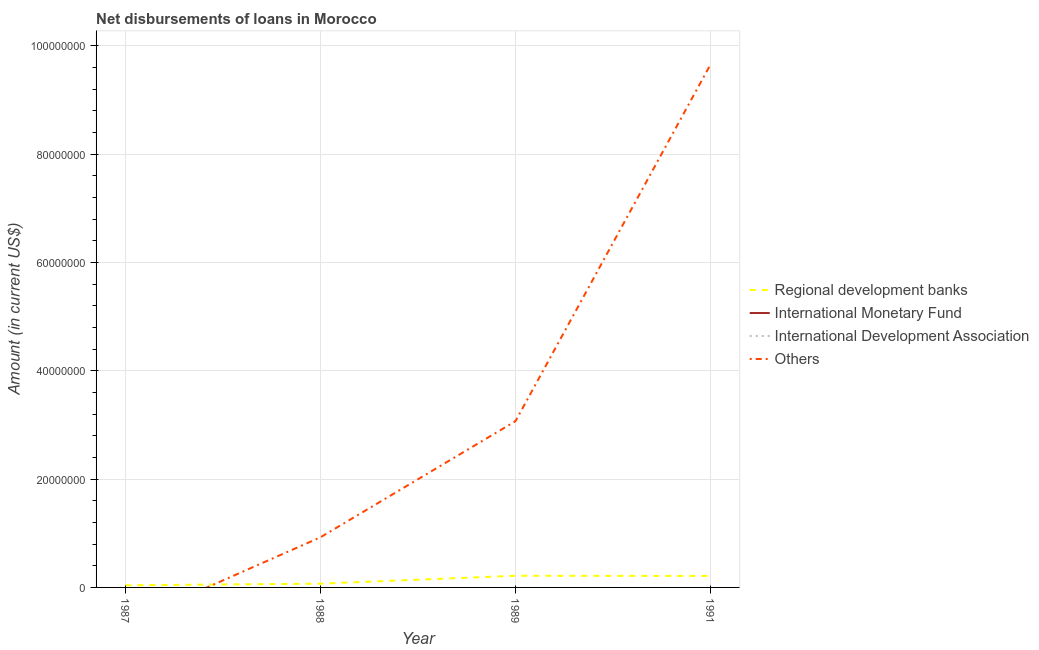Does the line corresponding to amount of loan disimbursed by regional development banks intersect with the line corresponding to amount of loan disimbursed by other organisations?
Your answer should be very brief. Yes. Is the number of lines equal to the number of legend labels?
Provide a short and direct response. No. What is the amount of loan disimbursed by regional development banks in 1988?
Your answer should be very brief. 6.94e+05. Across all years, what is the maximum amount of loan disimbursed by other organisations?
Offer a terse response. 9.66e+07. What is the total amount of loan disimbursed by international monetary fund in the graph?
Provide a succinct answer. 0. What is the difference between the amount of loan disimbursed by other organisations in 1989 and that in 1991?
Provide a short and direct response. -6.59e+07. What is the difference between the amount of loan disimbursed by international development association in 1988 and the amount of loan disimbursed by other organisations in 1987?
Offer a terse response. 0. What is the average amount of loan disimbursed by other organisations per year?
Your answer should be compact. 3.41e+07. In the year 1989, what is the difference between the amount of loan disimbursed by other organisations and amount of loan disimbursed by regional development banks?
Provide a short and direct response. 2.85e+07. What is the ratio of the amount of loan disimbursed by regional development banks in 1987 to that in 1988?
Your answer should be compact. 0.57. What is the difference between the highest and the second highest amount of loan disimbursed by regional development banks?
Provide a succinct answer. 3.50e+04. What is the difference between the highest and the lowest amount of loan disimbursed by other organisations?
Offer a very short reply. 9.66e+07. In how many years, is the amount of loan disimbursed by international monetary fund greater than the average amount of loan disimbursed by international monetary fund taken over all years?
Keep it short and to the point. 0. Is the sum of the amount of loan disimbursed by regional development banks in 1987 and 1988 greater than the maximum amount of loan disimbursed by international monetary fund across all years?
Your response must be concise. Yes. Is it the case that in every year, the sum of the amount of loan disimbursed by regional development banks and amount of loan disimbursed by international monetary fund is greater than the amount of loan disimbursed by international development association?
Your response must be concise. Yes. Does the amount of loan disimbursed by other organisations monotonically increase over the years?
Your response must be concise. Yes. How many lines are there?
Your answer should be compact. 2. How many years are there in the graph?
Make the answer very short. 4. Does the graph contain any zero values?
Give a very brief answer. Yes. How many legend labels are there?
Make the answer very short. 4. How are the legend labels stacked?
Your answer should be compact. Vertical. What is the title of the graph?
Ensure brevity in your answer.  Net disbursements of loans in Morocco. What is the label or title of the X-axis?
Provide a short and direct response. Year. What is the Amount (in current US$) in Regional development banks in 1987?
Your answer should be very brief. 3.99e+05. What is the Amount (in current US$) of Regional development banks in 1988?
Offer a terse response. 6.94e+05. What is the Amount (in current US$) in International Monetary Fund in 1988?
Your response must be concise. 0. What is the Amount (in current US$) of International Development Association in 1988?
Provide a succinct answer. 0. What is the Amount (in current US$) of Others in 1988?
Provide a short and direct response. 9.26e+06. What is the Amount (in current US$) in Regional development banks in 1989?
Your answer should be compact. 2.16e+06. What is the Amount (in current US$) of International Development Association in 1989?
Make the answer very short. 0. What is the Amount (in current US$) of Others in 1989?
Your response must be concise. 3.07e+07. What is the Amount (in current US$) of Regional development banks in 1991?
Provide a short and direct response. 2.12e+06. What is the Amount (in current US$) in International Monetary Fund in 1991?
Offer a very short reply. 0. What is the Amount (in current US$) of International Development Association in 1991?
Your response must be concise. 0. What is the Amount (in current US$) of Others in 1991?
Your answer should be compact. 9.66e+07. Across all years, what is the maximum Amount (in current US$) of Regional development banks?
Your answer should be very brief. 2.16e+06. Across all years, what is the maximum Amount (in current US$) of Others?
Provide a succinct answer. 9.66e+07. Across all years, what is the minimum Amount (in current US$) in Regional development banks?
Offer a terse response. 3.99e+05. Across all years, what is the minimum Amount (in current US$) of Others?
Provide a short and direct response. 0. What is the total Amount (in current US$) of Regional development banks in the graph?
Your response must be concise. 5.37e+06. What is the total Amount (in current US$) in International Development Association in the graph?
Provide a short and direct response. 0. What is the total Amount (in current US$) of Others in the graph?
Offer a very short reply. 1.37e+08. What is the difference between the Amount (in current US$) in Regional development banks in 1987 and that in 1988?
Keep it short and to the point. -2.95e+05. What is the difference between the Amount (in current US$) in Regional development banks in 1987 and that in 1989?
Ensure brevity in your answer.  -1.76e+06. What is the difference between the Amount (in current US$) of Regional development banks in 1987 and that in 1991?
Ensure brevity in your answer.  -1.72e+06. What is the difference between the Amount (in current US$) of Regional development banks in 1988 and that in 1989?
Your response must be concise. -1.46e+06. What is the difference between the Amount (in current US$) in Others in 1988 and that in 1989?
Your response must be concise. -2.14e+07. What is the difference between the Amount (in current US$) in Regional development banks in 1988 and that in 1991?
Offer a very short reply. -1.43e+06. What is the difference between the Amount (in current US$) in Others in 1988 and that in 1991?
Keep it short and to the point. -8.73e+07. What is the difference between the Amount (in current US$) in Regional development banks in 1989 and that in 1991?
Provide a short and direct response. 3.50e+04. What is the difference between the Amount (in current US$) of Others in 1989 and that in 1991?
Keep it short and to the point. -6.59e+07. What is the difference between the Amount (in current US$) of Regional development banks in 1987 and the Amount (in current US$) of Others in 1988?
Keep it short and to the point. -8.86e+06. What is the difference between the Amount (in current US$) in Regional development banks in 1987 and the Amount (in current US$) in Others in 1989?
Offer a very short reply. -3.03e+07. What is the difference between the Amount (in current US$) of Regional development banks in 1987 and the Amount (in current US$) of Others in 1991?
Your answer should be very brief. -9.62e+07. What is the difference between the Amount (in current US$) in Regional development banks in 1988 and the Amount (in current US$) in Others in 1989?
Make the answer very short. -3.00e+07. What is the difference between the Amount (in current US$) in Regional development banks in 1988 and the Amount (in current US$) in Others in 1991?
Keep it short and to the point. -9.59e+07. What is the difference between the Amount (in current US$) in Regional development banks in 1989 and the Amount (in current US$) in Others in 1991?
Ensure brevity in your answer.  -9.44e+07. What is the average Amount (in current US$) of Regional development banks per year?
Provide a succinct answer. 1.34e+06. What is the average Amount (in current US$) of International Monetary Fund per year?
Your answer should be very brief. 0. What is the average Amount (in current US$) in International Development Association per year?
Your answer should be very brief. 0. What is the average Amount (in current US$) of Others per year?
Provide a succinct answer. 3.41e+07. In the year 1988, what is the difference between the Amount (in current US$) in Regional development banks and Amount (in current US$) in Others?
Offer a very short reply. -8.56e+06. In the year 1989, what is the difference between the Amount (in current US$) of Regional development banks and Amount (in current US$) of Others?
Provide a short and direct response. -2.85e+07. In the year 1991, what is the difference between the Amount (in current US$) of Regional development banks and Amount (in current US$) of Others?
Your answer should be compact. -9.44e+07. What is the ratio of the Amount (in current US$) of Regional development banks in 1987 to that in 1988?
Your answer should be compact. 0.57. What is the ratio of the Amount (in current US$) of Regional development banks in 1987 to that in 1989?
Give a very brief answer. 0.19. What is the ratio of the Amount (in current US$) in Regional development banks in 1987 to that in 1991?
Your answer should be very brief. 0.19. What is the ratio of the Amount (in current US$) of Regional development banks in 1988 to that in 1989?
Ensure brevity in your answer.  0.32. What is the ratio of the Amount (in current US$) of Others in 1988 to that in 1989?
Your answer should be compact. 0.3. What is the ratio of the Amount (in current US$) of Regional development banks in 1988 to that in 1991?
Your answer should be very brief. 0.33. What is the ratio of the Amount (in current US$) in Others in 1988 to that in 1991?
Offer a very short reply. 0.1. What is the ratio of the Amount (in current US$) of Regional development banks in 1989 to that in 1991?
Provide a succinct answer. 1.02. What is the ratio of the Amount (in current US$) of Others in 1989 to that in 1991?
Your answer should be very brief. 0.32. What is the difference between the highest and the second highest Amount (in current US$) of Regional development banks?
Make the answer very short. 3.50e+04. What is the difference between the highest and the second highest Amount (in current US$) of Others?
Offer a very short reply. 6.59e+07. What is the difference between the highest and the lowest Amount (in current US$) of Regional development banks?
Provide a succinct answer. 1.76e+06. What is the difference between the highest and the lowest Amount (in current US$) in Others?
Your answer should be very brief. 9.66e+07. 